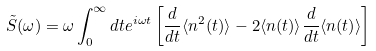<formula> <loc_0><loc_0><loc_500><loc_500>& \tilde { S } ( \omega ) = \omega \int _ { 0 } ^ { \infty } d t e ^ { i \omega t } \left [ \frac { d } { d t } \langle n ^ { 2 } ( t ) \rangle - 2 \langle n ( t ) \rangle \frac { d } { d t } \langle n ( t ) \rangle \right ]</formula> 